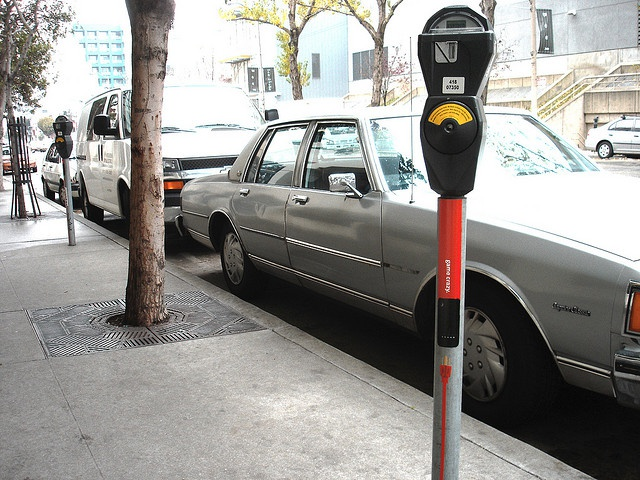Describe the objects in this image and their specific colors. I can see car in brown, black, white, gray, and darkgray tones, truck in brown, white, black, darkgray, and gray tones, parking meter in brown, black, gray, darkgray, and lightgray tones, car in brown, white, darkgray, gray, and black tones, and car in brown, white, black, darkgray, and gray tones in this image. 